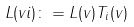<formula> <loc_0><loc_0><loc_500><loc_500>L ( v i ) \colon = L ( v ) T _ { i } ( v )</formula> 